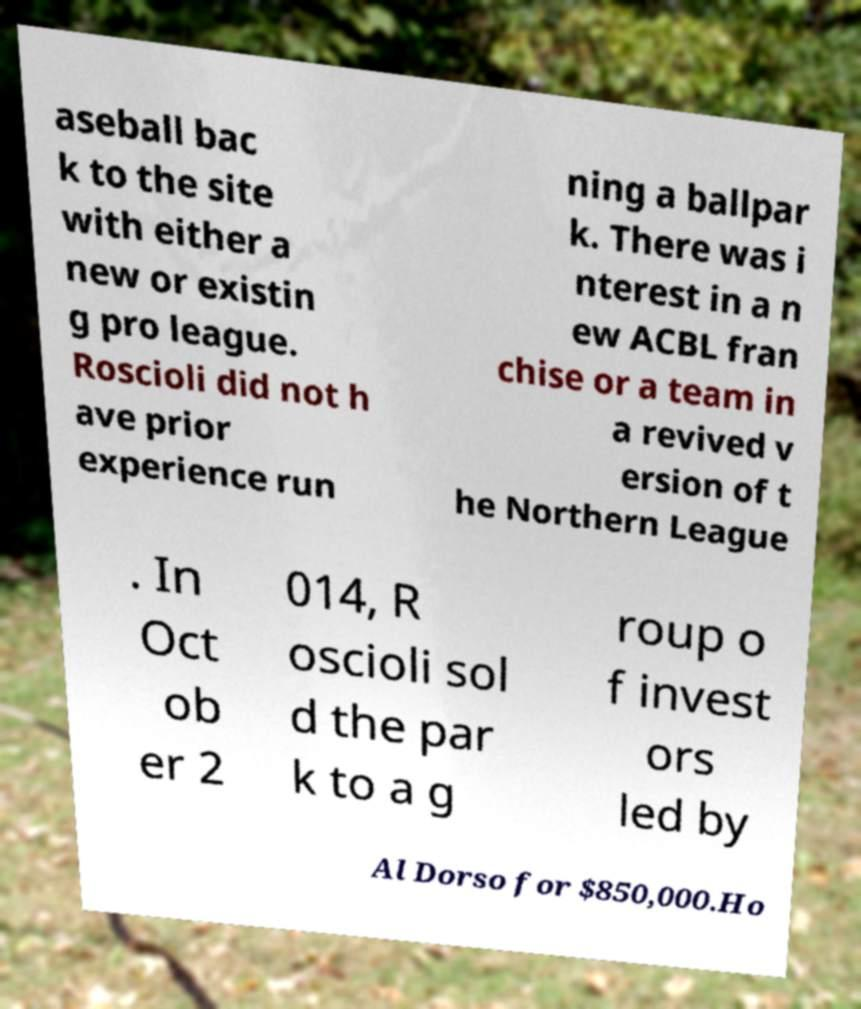What messages or text are displayed in this image? I need them in a readable, typed format. aseball bac k to the site with either a new or existin g pro league. Roscioli did not h ave prior experience run ning a ballpar k. There was i nterest in a n ew ACBL fran chise or a team in a revived v ersion of t he Northern League . In Oct ob er 2 014, R oscioli sol d the par k to a g roup o f invest ors led by Al Dorso for $850,000.Ho 